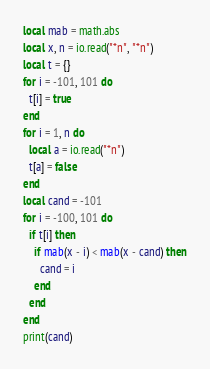Convert code to text. <code><loc_0><loc_0><loc_500><loc_500><_Lua_>local mab = math.abs
local x, n = io.read("*n", "*n")
local t = {}
for i = -101, 101 do
  t[i] = true
end
for i = 1, n do
  local a = io.read("*n")
  t[a] = false
end
local cand = -101
for i = -100, 101 do
  if t[i] then
    if mab(x - i) < mab(x - cand) then
      cand = i
    end
  end
end
print(cand)
</code> 